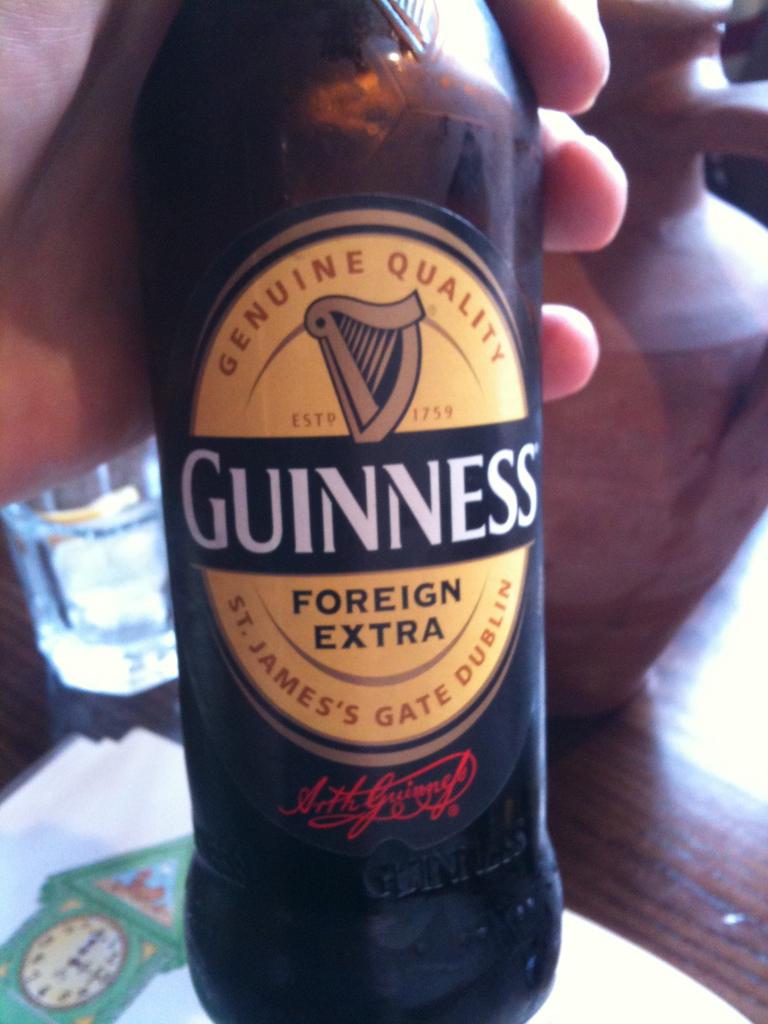Does the drink contain alcohol?
Your answer should be very brief. Yes. What brand of beer is this?
Offer a terse response. Guinness. 